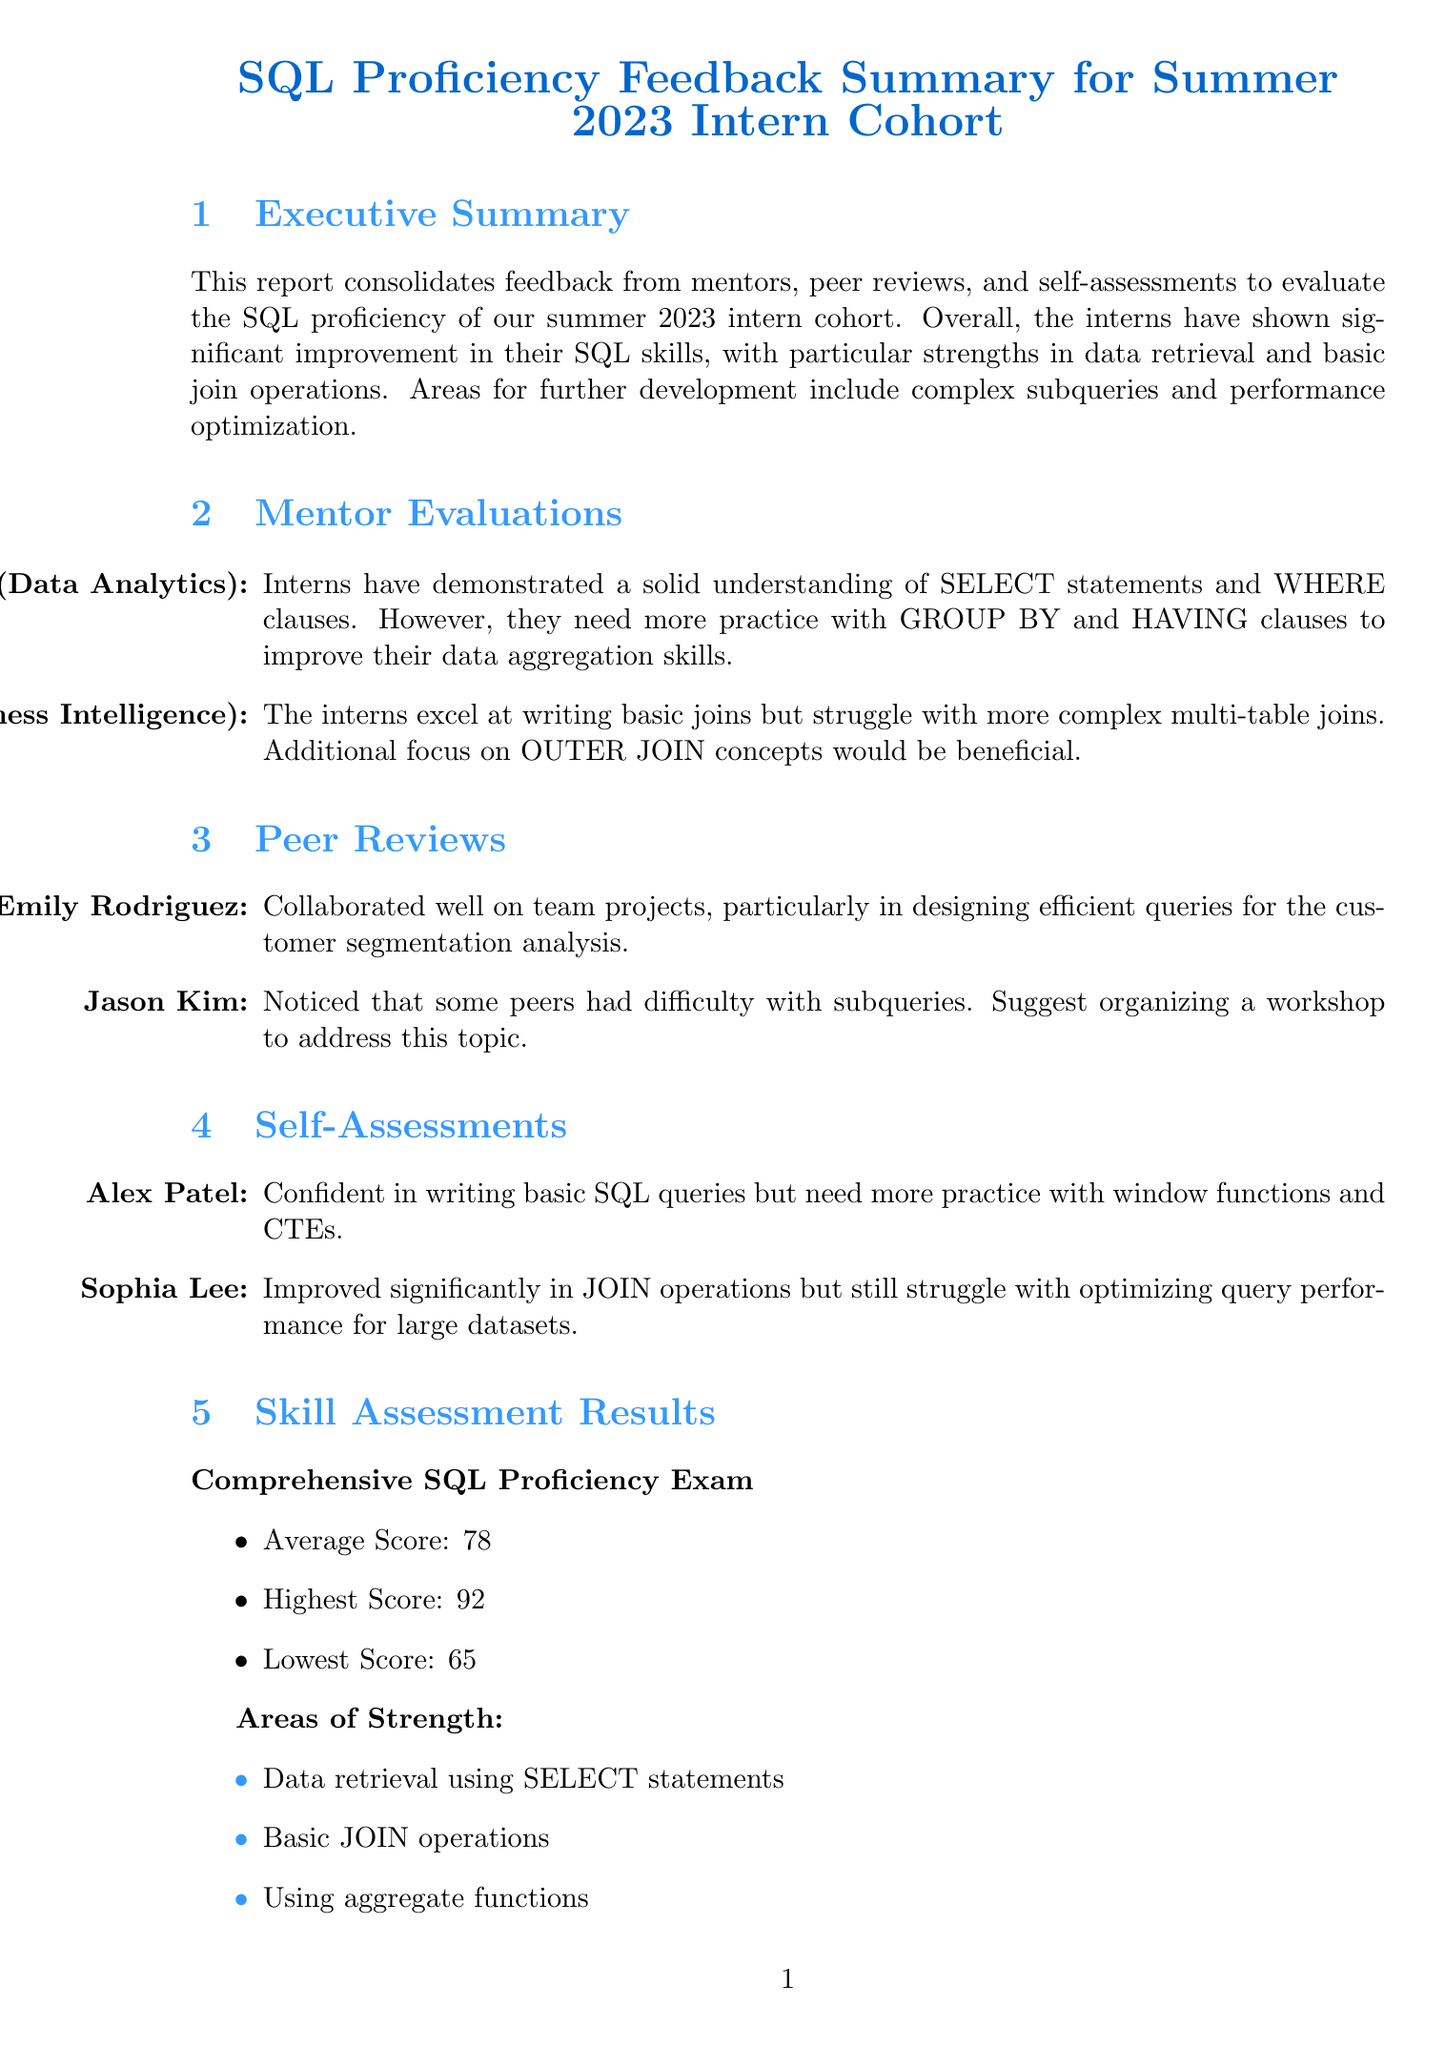What is the title of the report? The title of the report is explicitly stated at the beginning of the document.
Answer: SQL Proficiency Feedback Summary for Summer 2023 Intern Cohort Who prepared the report? The preparer's name is mentioned in the metadata section of the document.
Answer: Jordan Alvarez What is the average score from the SQL proficiency exam? The average score is one of the key metrics summarized in the skill assessment results.
Answer: 78 What areas of strength were identified in the interns? The areas of strength are listed in a specific section within the document.
Answer: Data retrieval using SELECT statements, Basic JOIN operations, Using aggregate functions Name one area for improvement identified for the interns. The document outlines specific areas that require further development for the interns.
Answer: Complex subqueries Which intern expressed confidence in writing basic SQL queries? This information is found under the self-assessment section where interns evaluate themselves.
Answer: Alex Patel What recommendation is made for improving problem-solving skills? Recommendations are provided to enhance the interns' SQL capabilities, focusing on practical exercises.
Answer: Organize weekly SQL challenge sessions to improve problem-solving skills When was the report prepared? The preparation date is specified in the metadata at the end of the document.
Answer: 2023-07-15 What is one suggested next step for the management? The next steps section outlines actions to be taken after evaluating the interns.
Answer: Schedule one-on-one meetings with each intern to discuss their progress and areas for improvement 